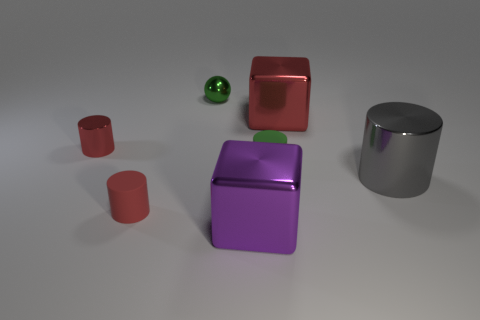Subtract all gray cylinders. How many cylinders are left? 3 Add 2 purple matte cubes. How many objects exist? 9 Subtract all brown cylinders. Subtract all blue blocks. How many cylinders are left? 4 Subtract all cubes. How many objects are left? 5 Subtract all big red things. Subtract all tiny rubber cylinders. How many objects are left? 4 Add 5 tiny red shiny cylinders. How many tiny red shiny cylinders are left? 6 Add 4 green balls. How many green balls exist? 5 Subtract 0 yellow cylinders. How many objects are left? 7 